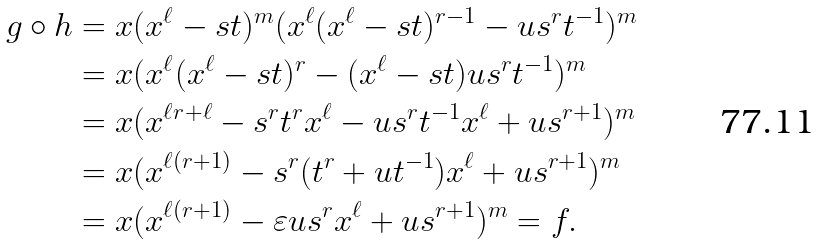<formula> <loc_0><loc_0><loc_500><loc_500>g \circ h & = x ( x ^ { \ell } - s t ) ^ { m } ( x ^ { \ell } ( x ^ { \ell } - s t ) ^ { r - 1 } - u s ^ { r } t ^ { - 1 } ) ^ { m } \\ & = x ( x ^ { \ell } ( x ^ { \ell } - s t ) ^ { r } - ( x ^ { \ell } - s t ) u s ^ { r } t ^ { - 1 } ) ^ { m } \\ & = x ( x ^ { \ell r + \ell } - s ^ { r } t ^ { r } x ^ { \ell } - u s ^ { r } t ^ { - 1 } x ^ { \ell } + u s ^ { r + 1 } ) ^ { m } \\ & = x ( x ^ { \ell ( r + 1 ) } - s ^ { r } ( t ^ { r } + u t ^ { - 1 } ) x ^ { \ell } + u s ^ { r + 1 } ) ^ { m } \\ & = x ( x ^ { \ell ( r + 1 ) } - \varepsilon u s ^ { r } x ^ { \ell } + u s ^ { r + 1 } ) ^ { m } = f .</formula> 